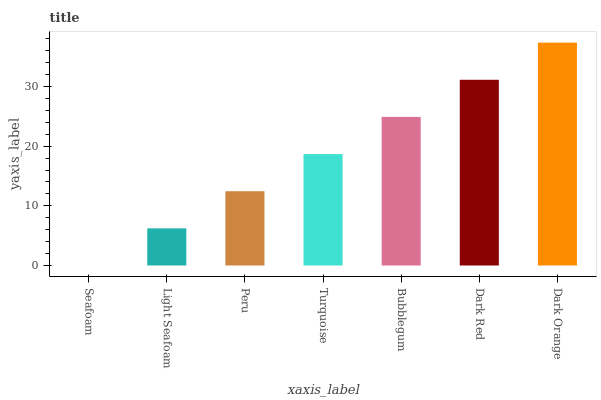Is Seafoam the minimum?
Answer yes or no. Yes. Is Dark Orange the maximum?
Answer yes or no. Yes. Is Light Seafoam the minimum?
Answer yes or no. No. Is Light Seafoam the maximum?
Answer yes or no. No. Is Light Seafoam greater than Seafoam?
Answer yes or no. Yes. Is Seafoam less than Light Seafoam?
Answer yes or no. Yes. Is Seafoam greater than Light Seafoam?
Answer yes or no. No. Is Light Seafoam less than Seafoam?
Answer yes or no. No. Is Turquoise the high median?
Answer yes or no. Yes. Is Turquoise the low median?
Answer yes or no. Yes. Is Seafoam the high median?
Answer yes or no. No. Is Peru the low median?
Answer yes or no. No. 